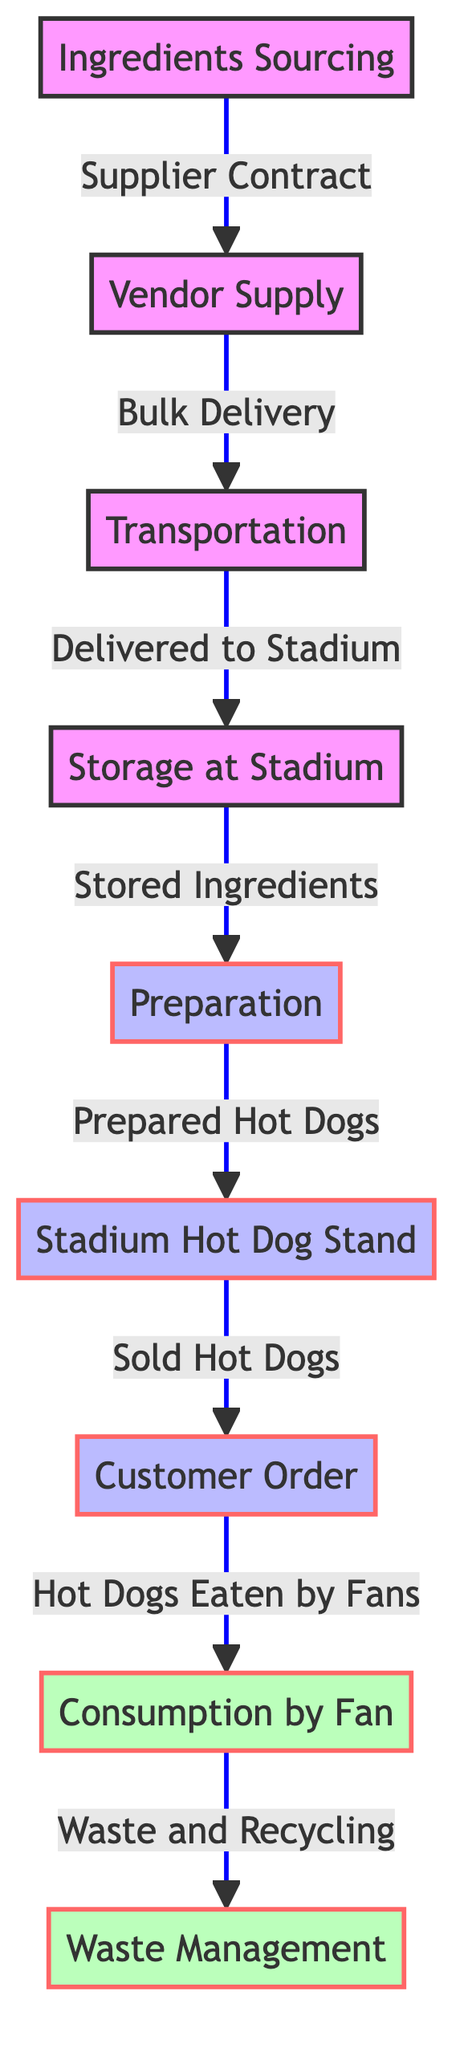What is the first step in the hot dog stand process? The diagram indicates that the first step is "Ingredients Sourcing," which is the initial stage before any other steps begin.
Answer: Ingredients Sourcing How many nodes are in the diagram? By counting each distinct element represented, there are eight nodes total in the flowchart: Ingredients Sourcing, Vendor Supply, Transportation, Storage at Stadium, Preparation, Stadium Hot Dog Stand, Customer Order, and Consumption by Fan.
Answer: Eight What connects the "Vendor Supply" to "Transportation"? The connection is described by the phrase "Bulk Delivery," indicating how vendor supplies are transported from the vendor to the stadium.
Answer: Bulk Delivery Which process follows the "Preparation"? Moving sequentially through the diagram, the process that follows "Preparation" is "Stadium Hot Dog Stand," where prepared hot dogs are sold.
Answer: Stadium Hot Dog Stand What is the final endpoint of the process? The last step in the chain, as shown, is "Waste Management," which occurs when the hot dogs are consumed and waste is generated.
Answer: Waste Management How is "Transportation" linked to "Storage at Stadium"? The link is defined by the phrase "Delivered to Stadium," which shows the process of transporting ingredients to the storage location within the stadium.
Answer: Delivered to Stadium What role does "Customer Order" play in the hot dog process? "Customer Order" represents the stage where hot dogs are sold to fans after they have been prepared at the stadium stand, making it a key transactional phase.
Answer: Hot Dogs Sold What happens after "Consumption by Fan"? Following "Consumption by Fan," the next action is "Waste and Recycling," indicating the need for managing leftovers and waste generated from consumed hot dogs.
Answer: Waste and Recycling 